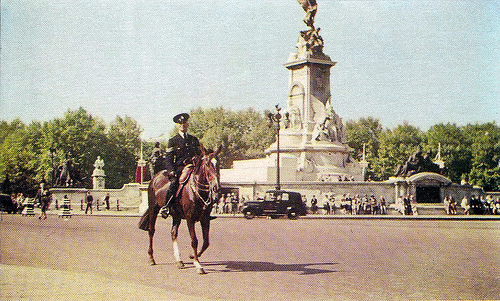Could you describe the attire of the person on the horse? Certainly, the individual mounted on the horse is wearing a uniform that suggests a formal role, possibly that of a police officer or a ceremonial guard. The attire includes a dark, peaked cap, traditionally styled high-collared tunic, perhaps with insignia or badges that denote rank or affiliation, white gloves, and dark riding pants with a lighter stripe. The uniform reflects an air of authority and is likely intended for official duties or ceremonial purposes. 